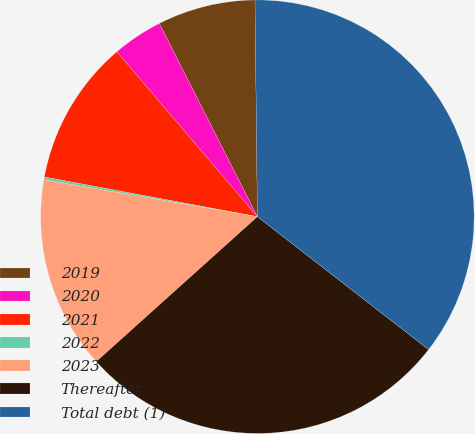<chart> <loc_0><loc_0><loc_500><loc_500><pie_chart><fcel>2019<fcel>2020<fcel>2021<fcel>2022<fcel>2023<fcel>Thereafter<fcel>Total debt (1)<nl><fcel>7.3%<fcel>3.75%<fcel>10.84%<fcel>0.2%<fcel>14.39%<fcel>27.84%<fcel>35.68%<nl></chart> 